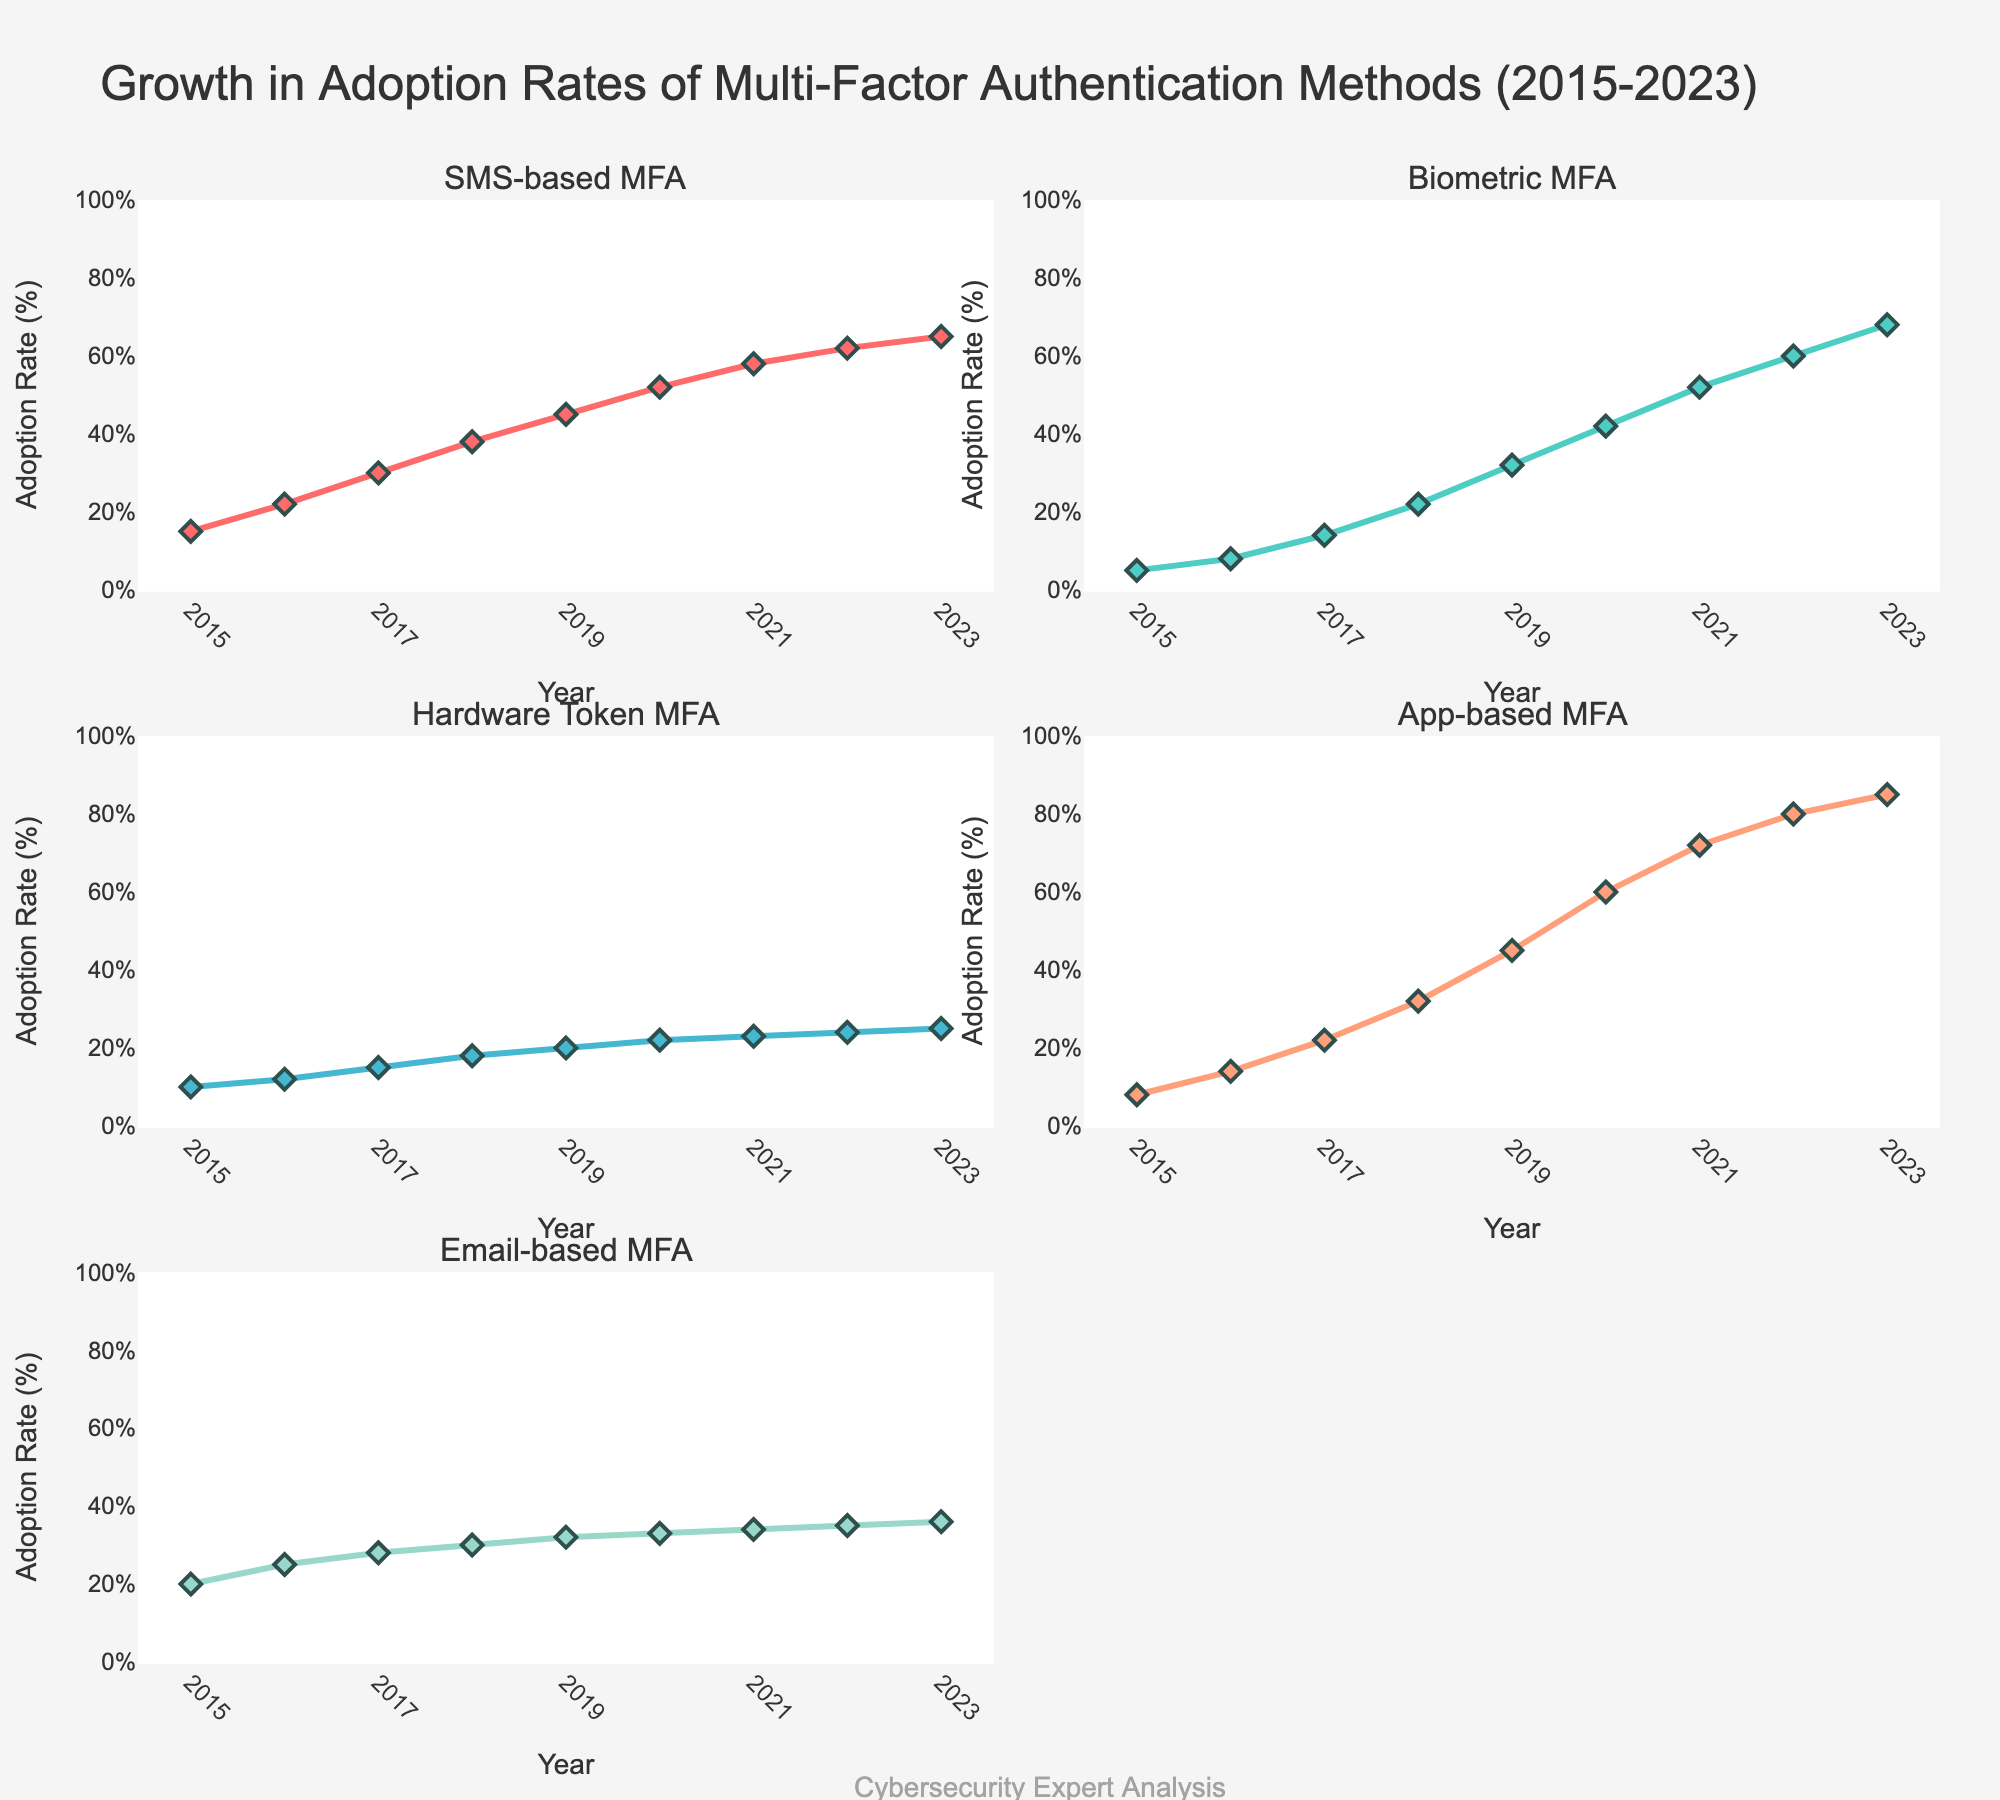What is the title of the figure? The title is usually located at the top of the figure and describes its main focus, which in this case is about the growth in adoption rates of multi-factor authentication methods by businesses between 2015 and 2023.
Answer: Growth in Adoption Rates of Multi-Factor Authentication Methods (2015-2023) Which MFA method had the highest adoption rate in 2023? By looking at the subplots for the year 2023, we find that the App-based MFA reached an adoption rate of 85%, which is the highest among all methods.
Answer: App-based MFA Between which two consecutive years did Email-based MFA see the smallest increase in adoption rate? By observing the trend line for Email-based MFA, the smallest increase occurred between 2022 and 2023, where adoption went from 35% to 36%, an increase of only 1%.
Answer: 2022 and 2023 What is the overall trend in adoption rates of Biometric MFA from 2015 to 2023? The subplot for Biometric MFA shows a steady increase every year from 2015, starting at 5% and reaching 68% in 2023, indicating a consistent upward trend.
Answer: Steady increase By how much did SMS-based MFA adoption rate increase from 2015 to 2023? To find the increase, subtract the adoption rate in 2015 (15%) from the rate in 2023 (65%). Thus, the increase is 65% - 15% = 50%.
Answer: 50% Which MFA method had the slowest growth in adoption rate by 2023? Comparing all subplots, Hardware Token MFA shows the slowest overall growth, moving from 10% in 2015 to 25% in 2023, a total increase of only 15%.
Answer: Hardware Token MFA How does the adoption rate of App-based MFA in 2020 compare to that of Biometric MFA in the same year? Looking at the subplots for 2020, the adoption rates were 60% for App-based MFA and 42% for Biometric MFA. Comparing these, App-based MFA had a higher adoption rate by 18%.
Answer: App-based MFA is higher by 18% What is the average adoption rate of Email-based MFA from 2015 to 2023? To calculate the average, sum the values for each year and divide by the number of years: (20 + 25 + 28 + 30 + 32 + 33 + 34 + 35 + 36) / 9 = 273 / 9 = 30.3%.
Answer: 30.3% Which two MFA methods had the most similar adoption rates in 2018, and what were those rates? In 2018, Email-based MFA had 30% and Hardware Token MFA had 18%. Comparing these, SMS-based MFA (38%) and App-based MFA (32%) had closer rates, differing by only 6%.
Answer: SMS-based MFA and App-based MFA at 38% and 32% Is there any year where all five MFA methods saw an increase in adoption rates compared to the previous year? By examining each subplot year over year, we see that each adoption rate increased compared to the previous year for all methods every year from 2015 to 2023.
Answer: Every year from 2015 to 2023 